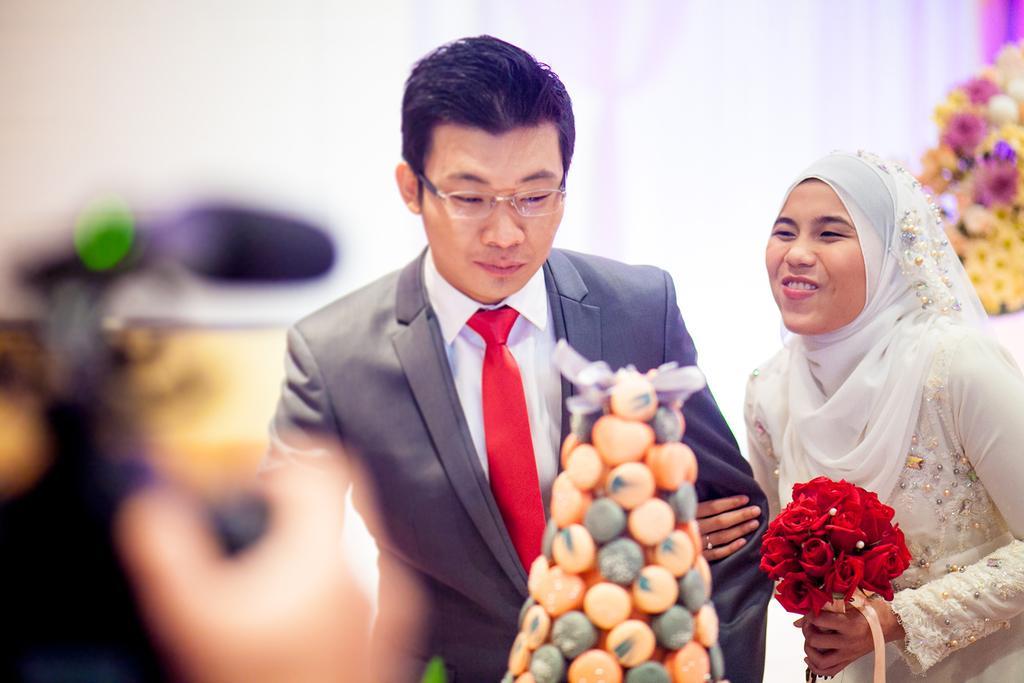Please provide a concise description of this image. In this image we can see a man wearing white color shirt, red tie and gray blazer and a woman wearing cream color dress holding red color roses and a person's hand holding the camera and in the background there are some flowers. 